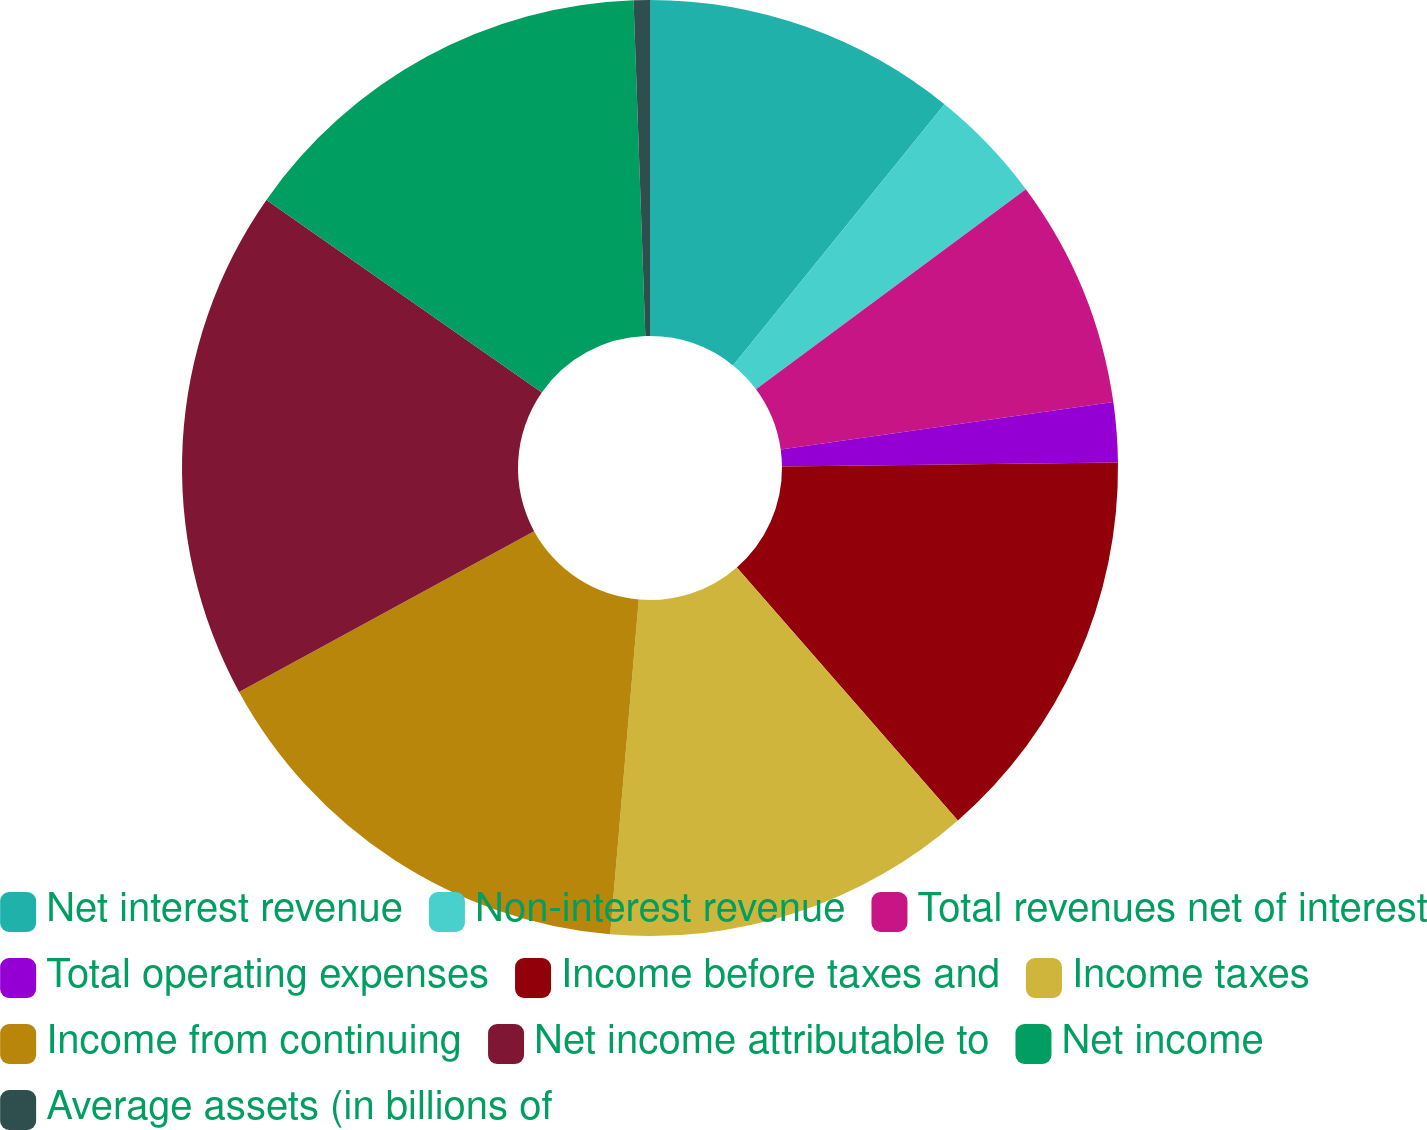<chart> <loc_0><loc_0><loc_500><loc_500><pie_chart><fcel>Net interest revenue<fcel>Non-interest revenue<fcel>Total revenues net of interest<fcel>Total operating expenses<fcel>Income before taxes and<fcel>Income taxes<fcel>Income from continuing<fcel>Net income attributable to<fcel>Net income<fcel>Average assets (in billions of<nl><fcel>10.83%<fcel>4.01%<fcel>7.91%<fcel>2.06%<fcel>13.76%<fcel>12.78%<fcel>15.7%<fcel>17.65%<fcel>14.73%<fcel>0.56%<nl></chart> 